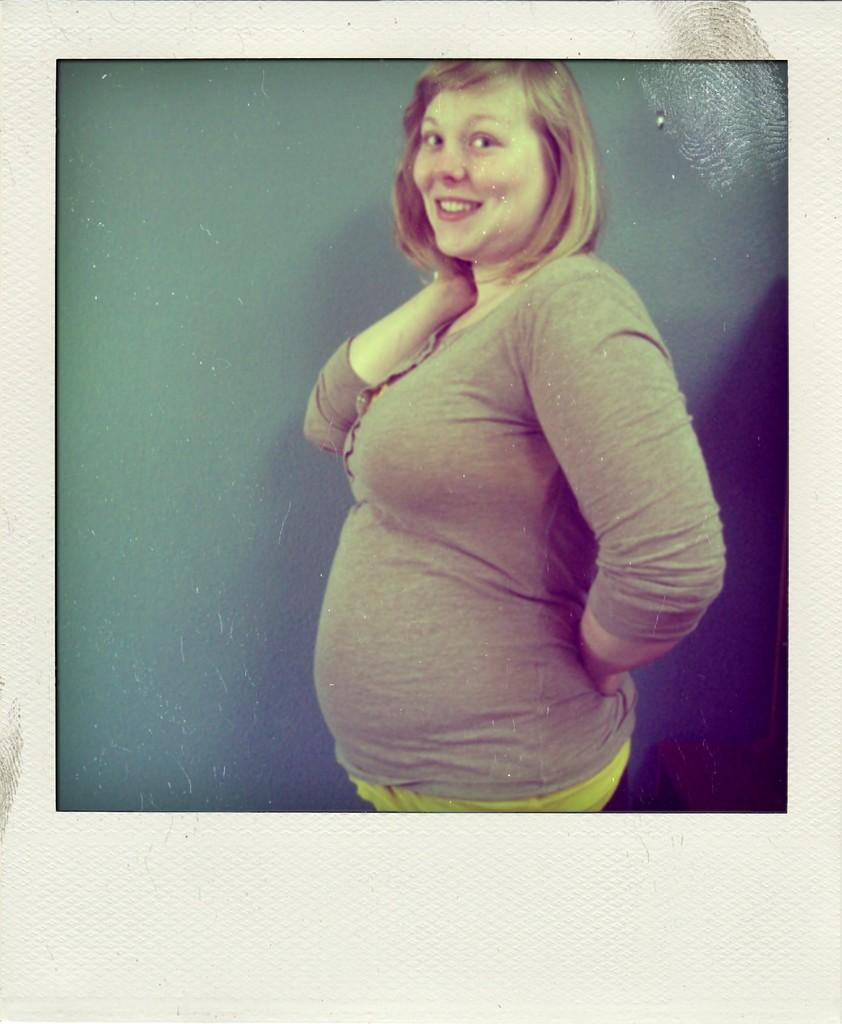What is the main subject of the image? There is a picture of a woman in the image. What is the woman doing in the image? The woman is standing. What is the most efficient route to the town depicted in the image? There is no town depicted in the image, as it only features a picture of a woman standing. What type of ornament is hanging from the woman's neck in the image? There is no ornament visible around the woman's neck in the image. 